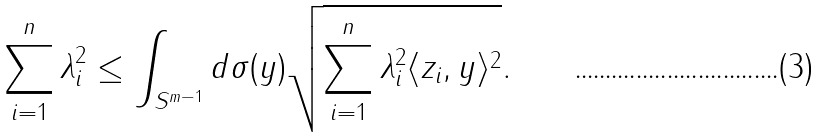Convert formula to latex. <formula><loc_0><loc_0><loc_500><loc_500>\sum _ { i = 1 } ^ { n } \lambda _ { i } ^ { 2 } \leq \int _ { S ^ { m - 1 } } { d \sigma ( y ) \sqrt { \sum _ { i = 1 } ^ { n } \lambda _ { i } ^ { 2 } \langle z _ { i } , y \rangle ^ { 2 } } } .</formula> 